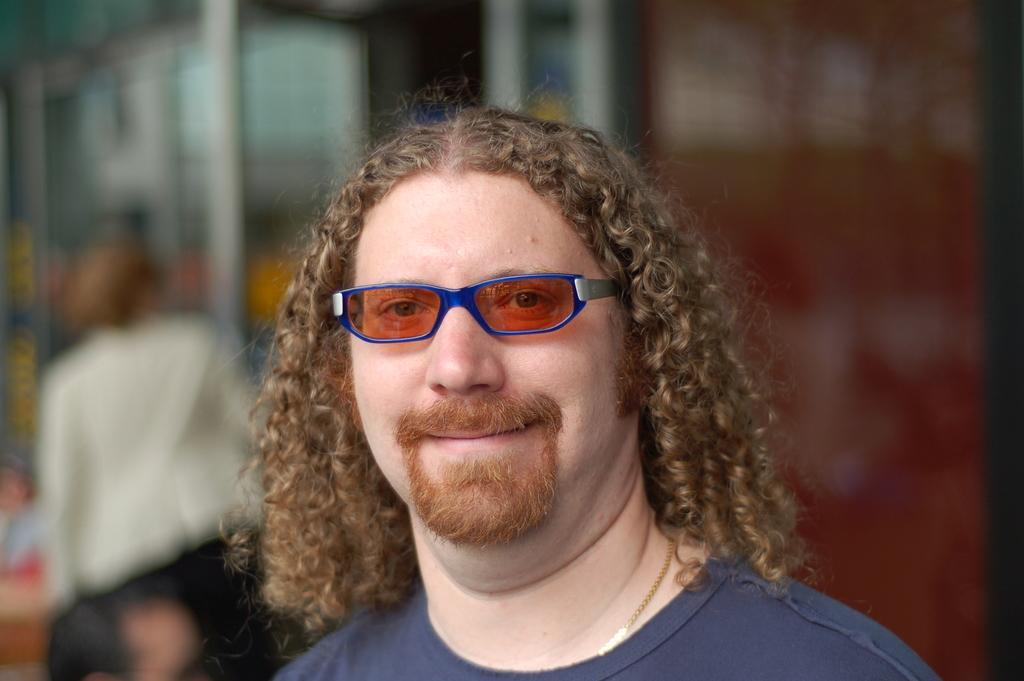Could you give a brief overview of what you see in this image? In this image I can see the person and the person is wearing blue color shirt and I can see the blurred background. 